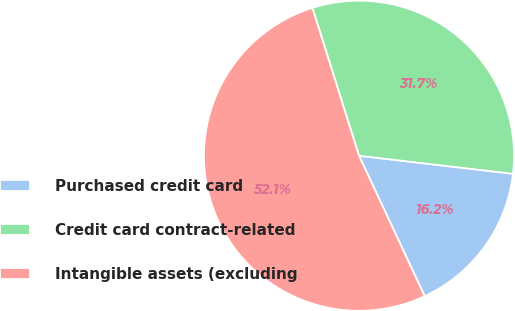Convert chart to OTSL. <chart><loc_0><loc_0><loc_500><loc_500><pie_chart><fcel>Purchased credit card<fcel>Credit card contract-related<fcel>Intangible assets (excluding<nl><fcel>16.18%<fcel>31.71%<fcel>52.1%<nl></chart> 